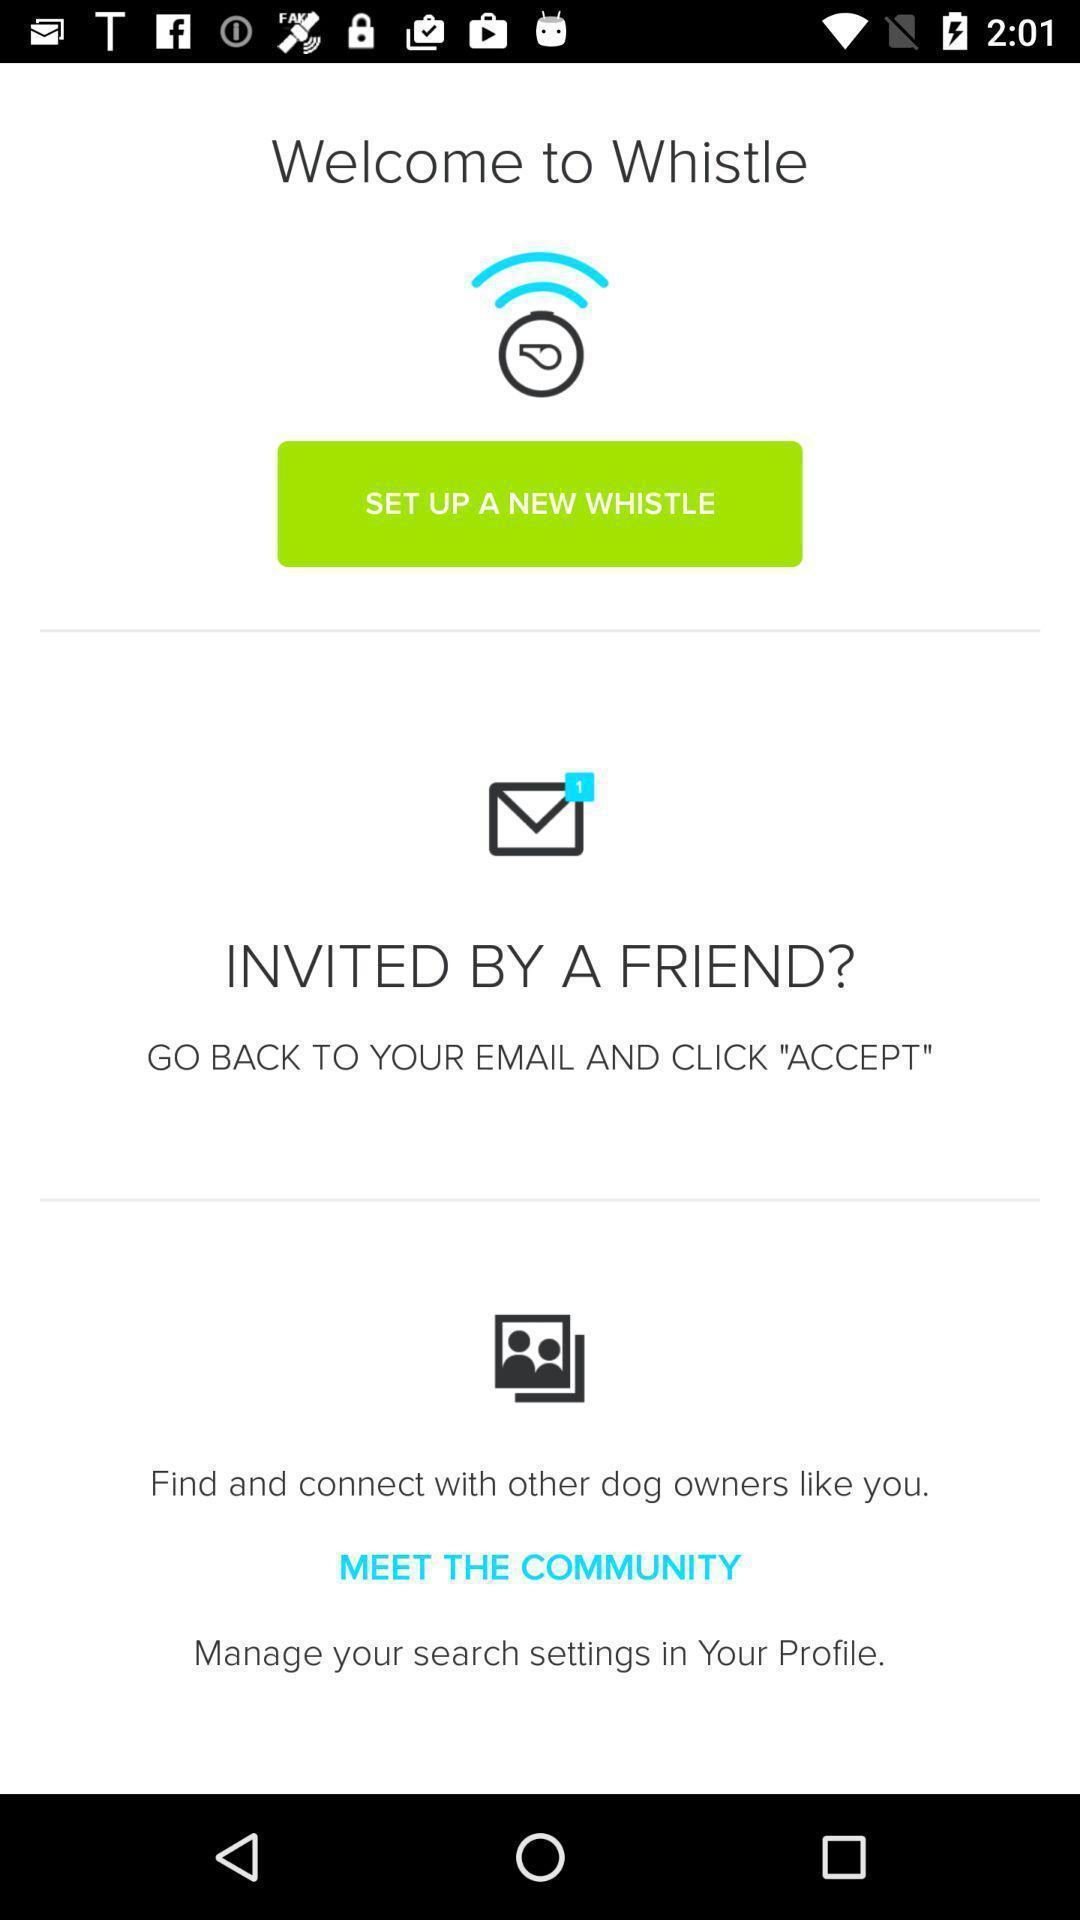Tell me what you see in this picture. Welcome page. 